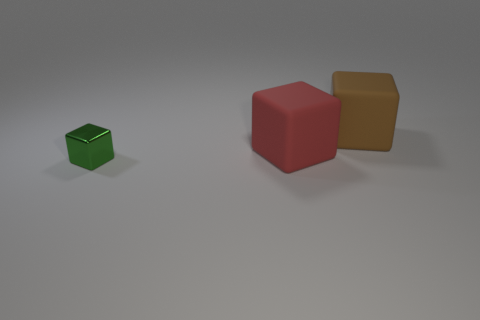What can you infer about the surface the cubes are resting on? The cubes rest on a flat, matte surface that has a slight gradient, becoming darker towards the bottom of the image. The texture appears smooth, and there's no reflection, suggesting it's not a glossy material.  Imagine if these were buildings, what kind of area would this represent? If these cubes were buildings, the image might represent a sparse, minimalist architectural layout in a planned urban space. The generous spacing between structures could indicate a design prioritizing open areas, possibly for a public square or park. 